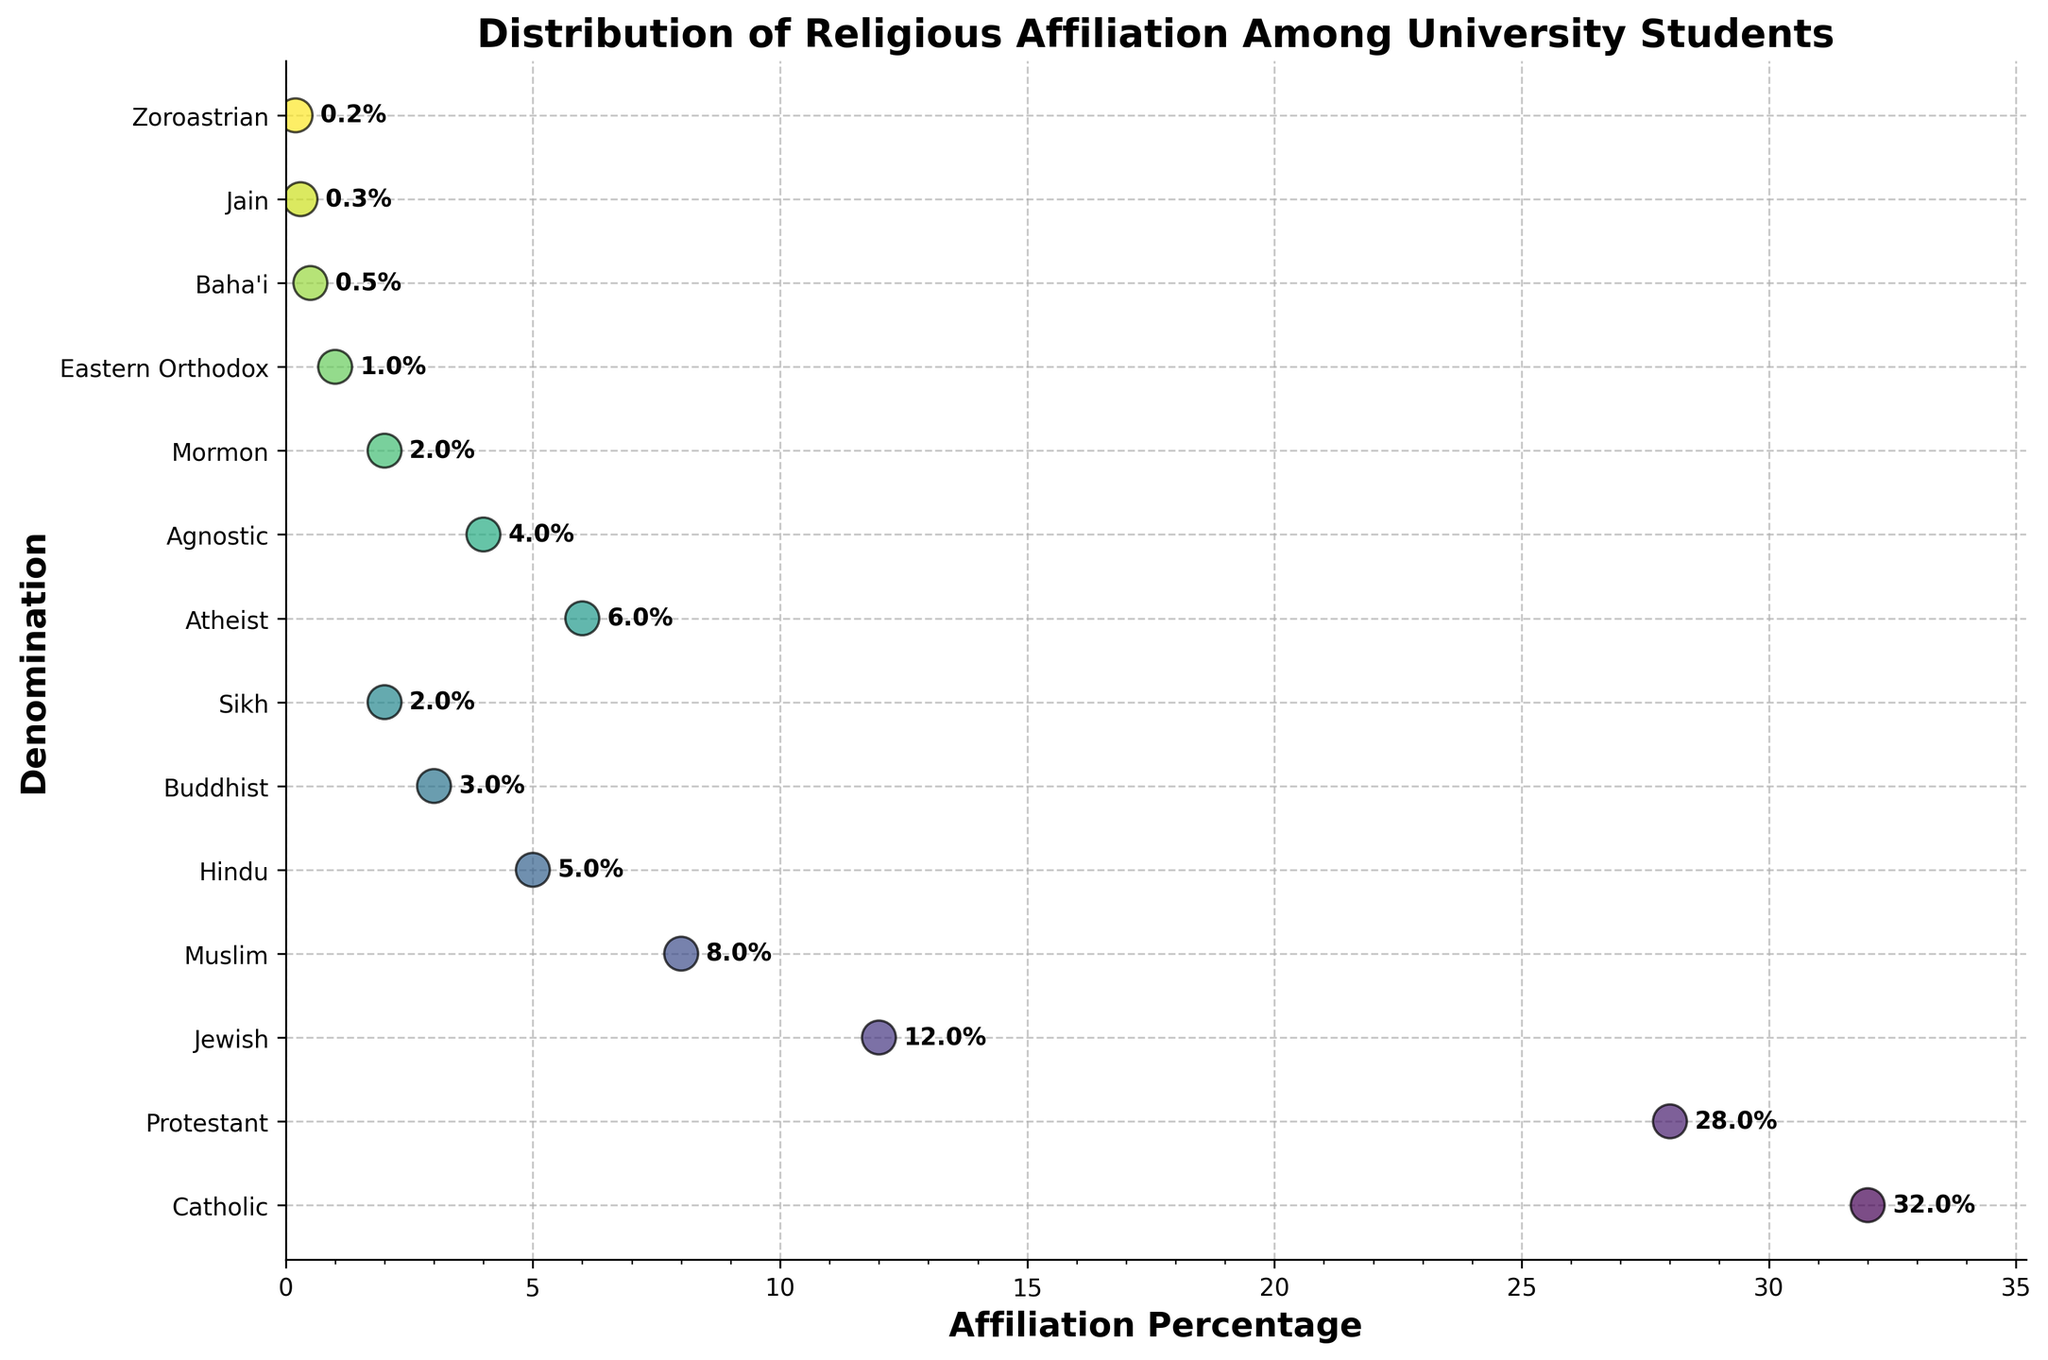What is the title of the plot? The title is written at the top of the plot. It reads "Distribution of Religious Affiliation Among University Students".
Answer: Distribution of Religious Affiliation Among University Students Which denomination has the highest affiliation percentage? The denominations are listed along the y-axis, and the percentages are shown on the x-axis. The denomination with the dot farthest to the right has the highest percentage. For this plot, it is "Catholic" with 32%.
Answer: Catholic How many denominations have an affiliation percentage of 5% or higher? Looking at the dots plotted along the x-axis, we count the number of denominations that have percentages of 5% or more. The denominations are Catholic, Protestant, Jewish, and Muslim.
Answer: 4 What is the combined percentage of denominations that have less than 1% affiliation? Identify the denominations with percentages less than 1% (Baha'i, Jain, and Zoroastrian) and sum their percentages: 0.5 + 0.3 + 0.2.
Answer: 1% Compare the affiliation percentages of Hindu and Buddhist students. Which group is larger and by how much? Locate Hindu and Buddhist on the y-axis and compare their positions on the x-axis. Hindu has 5% and Buddhist has 3%. The difference is 5% - 3%.
Answer: Hindu by 2% What is the median affiliation percentage among all denominations? To find the median, list all percentages in ascending order: 0.2, 0.3, 0.5, 1, 2, 2, 3, 4, 5, 6, 8, 12, 28, 32. The middle value in this list is 4.
Answer: 4 Which denominations have affiliation percentages lower than Atheist? Identify the percentage for Atheist (6%) and list denominations with a lower percentage: Agnostic, Mormon, Eastern Orthodox, Baha'i, Jain, and Zoroastrian.
Answer: Agnostic, Mormon, Eastern Orthodox, Baha'i, Jain, Zoroastrian What's the difference in affiliation percentage between the top two denominations? The top two denominations are Catholic (32%) and Protestant (28%). Subtract Protestant's percentage from Catholic's percentage: 32% - 28%.
Answer: 4% Which denomination has the smallest representation among university students? The dot closest to 0% on the x-axis represents the smallest percentage. Zoroastrian shows the smallest percentage with 0.2%.
Answer: Zoroastrian How many denominations have an affiliation percentage between 2% and 6%? Identify and count the denominations with percentages in this range: Hindu (5%), Buddhist (3%), Sikh (2%), Atheist (6%), and Agnostic (4%).
Answer: 5 